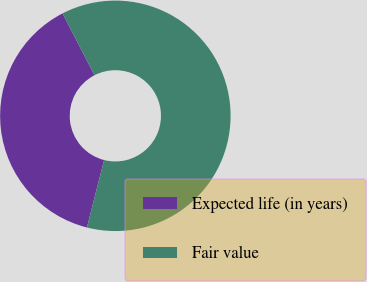Convert chart. <chart><loc_0><loc_0><loc_500><loc_500><pie_chart><fcel>Expected life (in years)<fcel>Fair value<nl><fcel>38.46%<fcel>61.54%<nl></chart> 